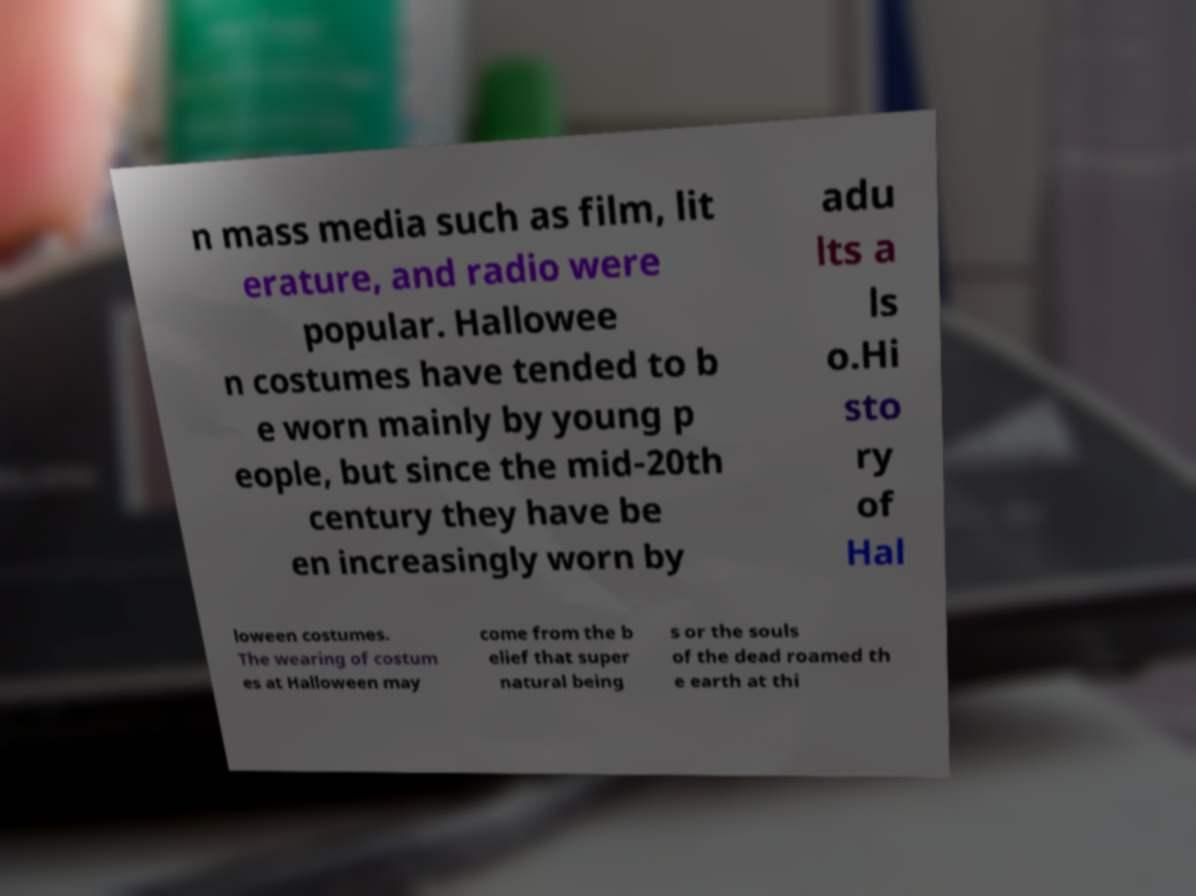For documentation purposes, I need the text within this image transcribed. Could you provide that? n mass media such as film, lit erature, and radio were popular. Hallowee n costumes have tended to b e worn mainly by young p eople, but since the mid-20th century they have be en increasingly worn by adu lts a ls o.Hi sto ry of Hal loween costumes. The wearing of costum es at Halloween may come from the b elief that super natural being s or the souls of the dead roamed th e earth at thi 